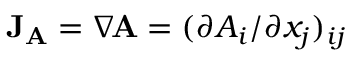<formula> <loc_0><loc_0><loc_500><loc_500>J _ { A } = \nabla \, A = ( \partial A _ { i } / \partial x _ { j } ) _ { i j }</formula> 